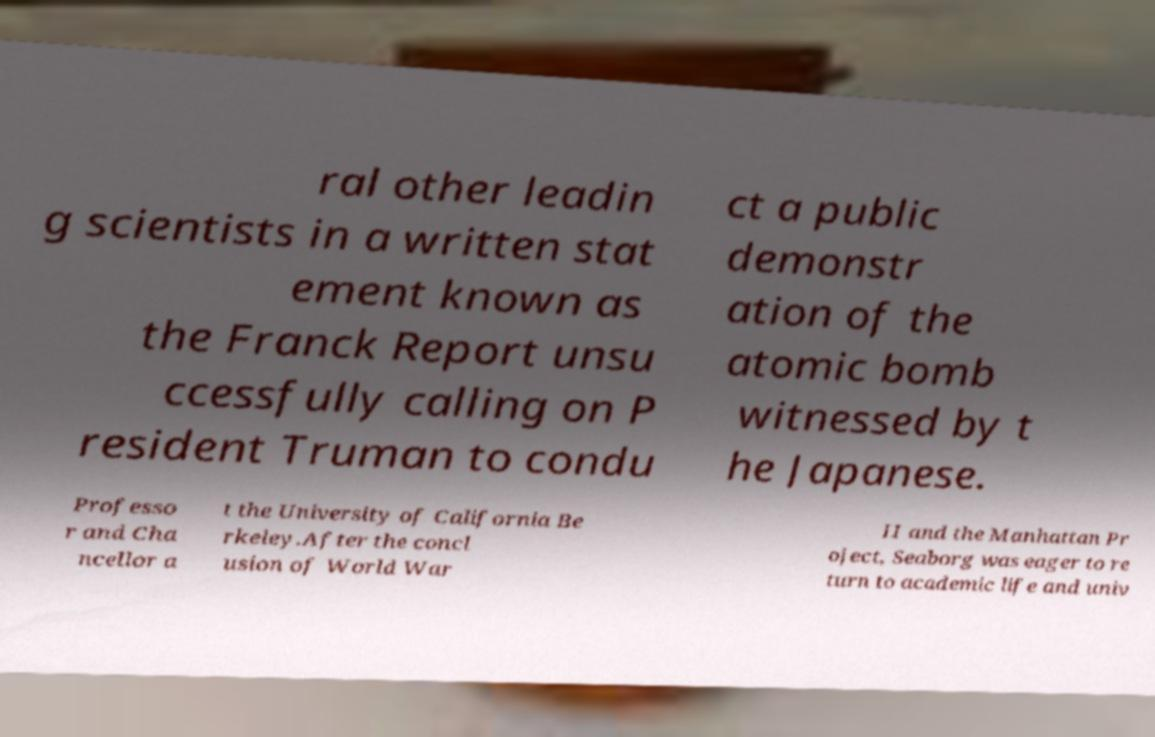For documentation purposes, I need the text within this image transcribed. Could you provide that? ral other leadin g scientists in a written stat ement known as the Franck Report unsu ccessfully calling on P resident Truman to condu ct a public demonstr ation of the atomic bomb witnessed by t he Japanese. Professo r and Cha ncellor a t the University of California Be rkeley.After the concl usion of World War II and the Manhattan Pr oject, Seaborg was eager to re turn to academic life and univ 